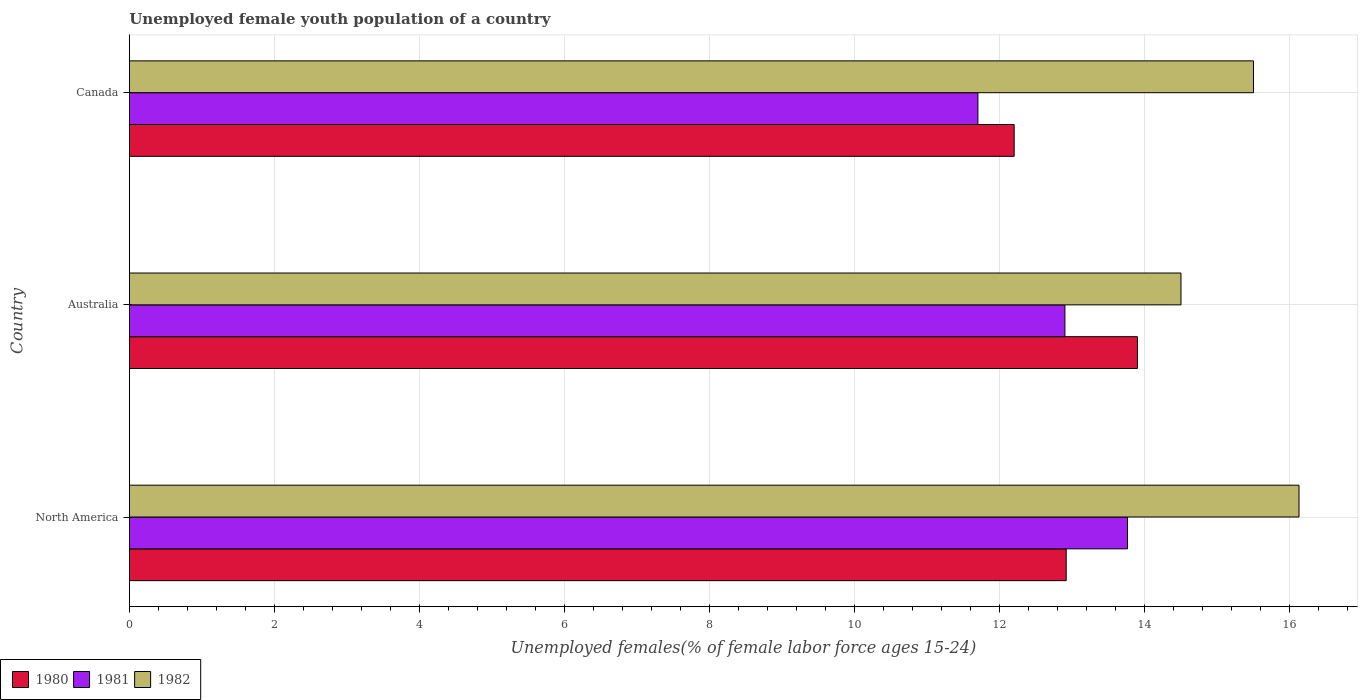How many groups of bars are there?
Your response must be concise. 3. How many bars are there on the 1st tick from the bottom?
Your answer should be very brief. 3. What is the label of the 3rd group of bars from the top?
Your answer should be very brief. North America. What is the percentage of unemployed female youth population in 1980 in Australia?
Your response must be concise. 13.9. Across all countries, what is the maximum percentage of unemployed female youth population in 1982?
Provide a succinct answer. 16.13. Across all countries, what is the minimum percentage of unemployed female youth population in 1982?
Offer a terse response. 14.5. In which country was the percentage of unemployed female youth population in 1982 minimum?
Offer a terse response. Australia. What is the total percentage of unemployed female youth population in 1981 in the graph?
Offer a very short reply. 38.36. What is the difference between the percentage of unemployed female youth population in 1982 in Australia and that in Canada?
Your answer should be very brief. -1. What is the difference between the percentage of unemployed female youth population in 1981 in North America and the percentage of unemployed female youth population in 1982 in Canada?
Give a very brief answer. -1.74. What is the average percentage of unemployed female youth population in 1981 per country?
Offer a very short reply. 12.79. What is the difference between the percentage of unemployed female youth population in 1982 and percentage of unemployed female youth population in 1981 in Canada?
Ensure brevity in your answer.  3.8. In how many countries, is the percentage of unemployed female youth population in 1980 greater than 15.6 %?
Keep it short and to the point. 0. What is the ratio of the percentage of unemployed female youth population in 1981 in Australia to that in Canada?
Ensure brevity in your answer.  1.1. Is the percentage of unemployed female youth population in 1982 in Australia less than that in North America?
Offer a very short reply. Yes. Is the difference between the percentage of unemployed female youth population in 1982 in Australia and Canada greater than the difference between the percentage of unemployed female youth population in 1981 in Australia and Canada?
Provide a short and direct response. No. What is the difference between the highest and the second highest percentage of unemployed female youth population in 1980?
Make the answer very short. 0.98. What is the difference between the highest and the lowest percentage of unemployed female youth population in 1980?
Your answer should be very brief. 1.7. In how many countries, is the percentage of unemployed female youth population in 1980 greater than the average percentage of unemployed female youth population in 1980 taken over all countries?
Offer a terse response. 1. What does the 2nd bar from the bottom in North America represents?
Offer a terse response. 1981. Is it the case that in every country, the sum of the percentage of unemployed female youth population in 1980 and percentage of unemployed female youth population in 1981 is greater than the percentage of unemployed female youth population in 1982?
Give a very brief answer. Yes. Are all the bars in the graph horizontal?
Your answer should be compact. Yes. How many countries are there in the graph?
Keep it short and to the point. 3. Are the values on the major ticks of X-axis written in scientific E-notation?
Give a very brief answer. No. Does the graph contain grids?
Provide a succinct answer. Yes. Where does the legend appear in the graph?
Offer a very short reply. Bottom left. How many legend labels are there?
Provide a short and direct response. 3. What is the title of the graph?
Offer a terse response. Unemployed female youth population of a country. Does "1978" appear as one of the legend labels in the graph?
Your answer should be very brief. No. What is the label or title of the X-axis?
Make the answer very short. Unemployed females(% of female labor force ages 15-24). What is the Unemployed females(% of female labor force ages 15-24) of 1980 in North America?
Offer a very short reply. 12.92. What is the Unemployed females(% of female labor force ages 15-24) in 1981 in North America?
Offer a very short reply. 13.76. What is the Unemployed females(% of female labor force ages 15-24) in 1982 in North America?
Provide a short and direct response. 16.13. What is the Unemployed females(% of female labor force ages 15-24) in 1980 in Australia?
Make the answer very short. 13.9. What is the Unemployed females(% of female labor force ages 15-24) in 1981 in Australia?
Offer a terse response. 12.9. What is the Unemployed females(% of female labor force ages 15-24) of 1982 in Australia?
Provide a succinct answer. 14.5. What is the Unemployed females(% of female labor force ages 15-24) of 1980 in Canada?
Make the answer very short. 12.2. What is the Unemployed females(% of female labor force ages 15-24) of 1981 in Canada?
Your answer should be very brief. 11.7. Across all countries, what is the maximum Unemployed females(% of female labor force ages 15-24) in 1980?
Your answer should be very brief. 13.9. Across all countries, what is the maximum Unemployed females(% of female labor force ages 15-24) of 1981?
Offer a terse response. 13.76. Across all countries, what is the maximum Unemployed females(% of female labor force ages 15-24) of 1982?
Make the answer very short. 16.13. Across all countries, what is the minimum Unemployed females(% of female labor force ages 15-24) of 1980?
Give a very brief answer. 12.2. Across all countries, what is the minimum Unemployed females(% of female labor force ages 15-24) in 1981?
Provide a short and direct response. 11.7. What is the total Unemployed females(% of female labor force ages 15-24) of 1980 in the graph?
Provide a succinct answer. 39.02. What is the total Unemployed females(% of female labor force ages 15-24) in 1981 in the graph?
Ensure brevity in your answer.  38.36. What is the total Unemployed females(% of female labor force ages 15-24) in 1982 in the graph?
Ensure brevity in your answer.  46.13. What is the difference between the Unemployed females(% of female labor force ages 15-24) of 1980 in North America and that in Australia?
Provide a short and direct response. -0.98. What is the difference between the Unemployed females(% of female labor force ages 15-24) in 1981 in North America and that in Australia?
Ensure brevity in your answer.  0.86. What is the difference between the Unemployed females(% of female labor force ages 15-24) in 1982 in North America and that in Australia?
Provide a short and direct response. 1.63. What is the difference between the Unemployed females(% of female labor force ages 15-24) of 1980 in North America and that in Canada?
Your answer should be very brief. 0.72. What is the difference between the Unemployed females(% of female labor force ages 15-24) of 1981 in North America and that in Canada?
Ensure brevity in your answer.  2.06. What is the difference between the Unemployed females(% of female labor force ages 15-24) of 1982 in North America and that in Canada?
Give a very brief answer. 0.63. What is the difference between the Unemployed females(% of female labor force ages 15-24) in 1980 in North America and the Unemployed females(% of female labor force ages 15-24) in 1981 in Australia?
Offer a very short reply. 0.02. What is the difference between the Unemployed females(% of female labor force ages 15-24) in 1980 in North America and the Unemployed females(% of female labor force ages 15-24) in 1982 in Australia?
Make the answer very short. -1.58. What is the difference between the Unemployed females(% of female labor force ages 15-24) of 1981 in North America and the Unemployed females(% of female labor force ages 15-24) of 1982 in Australia?
Offer a very short reply. -0.74. What is the difference between the Unemployed females(% of female labor force ages 15-24) in 1980 in North America and the Unemployed females(% of female labor force ages 15-24) in 1981 in Canada?
Give a very brief answer. 1.22. What is the difference between the Unemployed females(% of female labor force ages 15-24) of 1980 in North America and the Unemployed females(% of female labor force ages 15-24) of 1982 in Canada?
Provide a short and direct response. -2.58. What is the difference between the Unemployed females(% of female labor force ages 15-24) of 1981 in North America and the Unemployed females(% of female labor force ages 15-24) of 1982 in Canada?
Offer a terse response. -1.74. What is the difference between the Unemployed females(% of female labor force ages 15-24) of 1980 in Australia and the Unemployed females(% of female labor force ages 15-24) of 1981 in Canada?
Offer a terse response. 2.2. What is the difference between the Unemployed females(% of female labor force ages 15-24) of 1981 in Australia and the Unemployed females(% of female labor force ages 15-24) of 1982 in Canada?
Offer a terse response. -2.6. What is the average Unemployed females(% of female labor force ages 15-24) in 1980 per country?
Keep it short and to the point. 13.01. What is the average Unemployed females(% of female labor force ages 15-24) of 1981 per country?
Keep it short and to the point. 12.79. What is the average Unemployed females(% of female labor force ages 15-24) of 1982 per country?
Your response must be concise. 15.38. What is the difference between the Unemployed females(% of female labor force ages 15-24) of 1980 and Unemployed females(% of female labor force ages 15-24) of 1981 in North America?
Your answer should be compact. -0.85. What is the difference between the Unemployed females(% of female labor force ages 15-24) in 1980 and Unemployed females(% of female labor force ages 15-24) in 1982 in North America?
Keep it short and to the point. -3.21. What is the difference between the Unemployed females(% of female labor force ages 15-24) in 1981 and Unemployed females(% of female labor force ages 15-24) in 1982 in North America?
Keep it short and to the point. -2.37. What is the difference between the Unemployed females(% of female labor force ages 15-24) of 1980 and Unemployed females(% of female labor force ages 15-24) of 1981 in Australia?
Provide a short and direct response. 1. What is the difference between the Unemployed females(% of female labor force ages 15-24) in 1981 and Unemployed females(% of female labor force ages 15-24) in 1982 in Australia?
Your answer should be compact. -1.6. What is the difference between the Unemployed females(% of female labor force ages 15-24) in 1980 and Unemployed females(% of female labor force ages 15-24) in 1982 in Canada?
Provide a short and direct response. -3.3. What is the ratio of the Unemployed females(% of female labor force ages 15-24) in 1980 in North America to that in Australia?
Provide a short and direct response. 0.93. What is the ratio of the Unemployed females(% of female labor force ages 15-24) in 1981 in North America to that in Australia?
Ensure brevity in your answer.  1.07. What is the ratio of the Unemployed females(% of female labor force ages 15-24) in 1982 in North America to that in Australia?
Your response must be concise. 1.11. What is the ratio of the Unemployed females(% of female labor force ages 15-24) in 1980 in North America to that in Canada?
Make the answer very short. 1.06. What is the ratio of the Unemployed females(% of female labor force ages 15-24) of 1981 in North America to that in Canada?
Keep it short and to the point. 1.18. What is the ratio of the Unemployed females(% of female labor force ages 15-24) of 1982 in North America to that in Canada?
Your answer should be very brief. 1.04. What is the ratio of the Unemployed females(% of female labor force ages 15-24) in 1980 in Australia to that in Canada?
Your response must be concise. 1.14. What is the ratio of the Unemployed females(% of female labor force ages 15-24) in 1981 in Australia to that in Canada?
Your answer should be compact. 1.1. What is the ratio of the Unemployed females(% of female labor force ages 15-24) of 1982 in Australia to that in Canada?
Your answer should be very brief. 0.94. What is the difference between the highest and the second highest Unemployed females(% of female labor force ages 15-24) of 1980?
Offer a terse response. 0.98. What is the difference between the highest and the second highest Unemployed females(% of female labor force ages 15-24) in 1981?
Provide a short and direct response. 0.86. What is the difference between the highest and the second highest Unemployed females(% of female labor force ages 15-24) of 1982?
Your answer should be very brief. 0.63. What is the difference between the highest and the lowest Unemployed females(% of female labor force ages 15-24) in 1980?
Provide a short and direct response. 1.7. What is the difference between the highest and the lowest Unemployed females(% of female labor force ages 15-24) of 1981?
Offer a terse response. 2.06. What is the difference between the highest and the lowest Unemployed females(% of female labor force ages 15-24) of 1982?
Give a very brief answer. 1.63. 